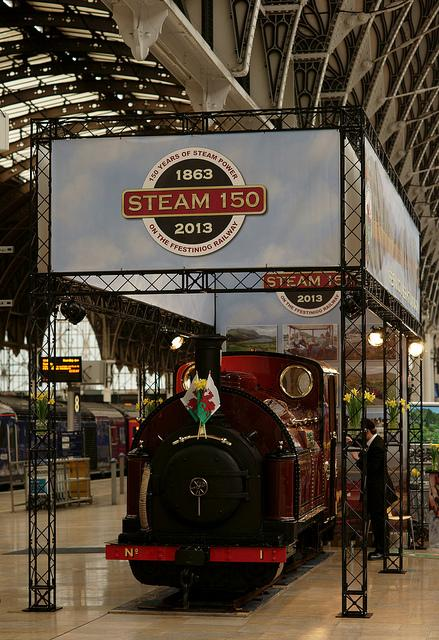Which anniversary is being celebrated? 150 